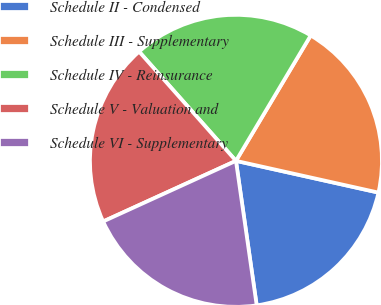<chart> <loc_0><loc_0><loc_500><loc_500><pie_chart><fcel>Schedule II - Condensed<fcel>Schedule III - Supplementary<fcel>Schedule IV - Reinsurance<fcel>Schedule V - Valuation and<fcel>Schedule VI - Supplementary<nl><fcel>19.24%<fcel>19.93%<fcel>20.1%<fcel>20.27%<fcel>20.45%<nl></chart> 